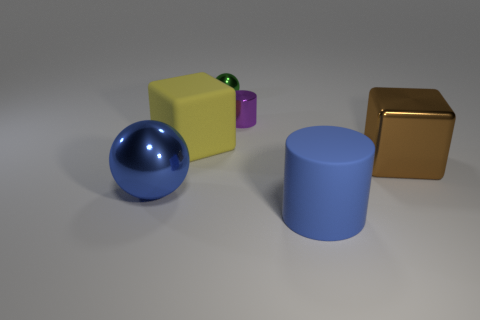Add 1 tiny brown metallic cylinders. How many objects exist? 7 Subtract all spheres. How many objects are left? 4 Add 2 large spheres. How many large spheres are left? 3 Add 6 cyan matte blocks. How many cyan matte blocks exist? 6 Subtract 0 red spheres. How many objects are left? 6 Subtract all blue spheres. Subtract all large shiny blocks. How many objects are left? 4 